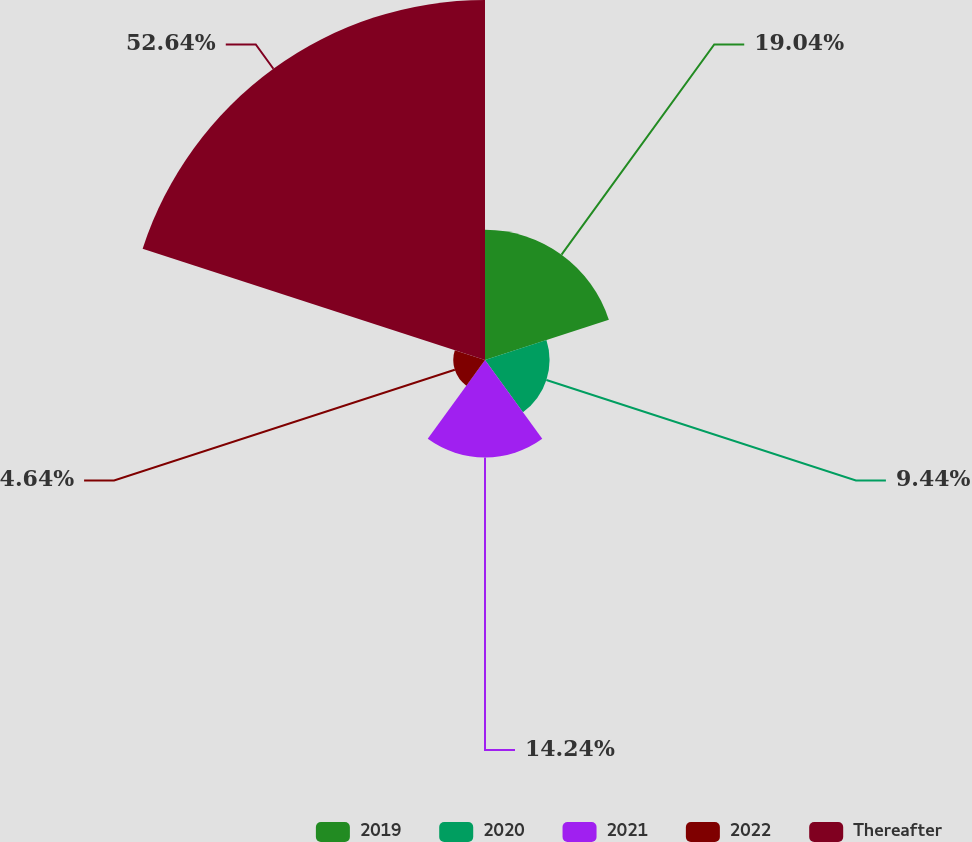Convert chart. <chart><loc_0><loc_0><loc_500><loc_500><pie_chart><fcel>2019<fcel>2020<fcel>2021<fcel>2022<fcel>Thereafter<nl><fcel>19.04%<fcel>9.44%<fcel>14.24%<fcel>4.64%<fcel>52.63%<nl></chart> 